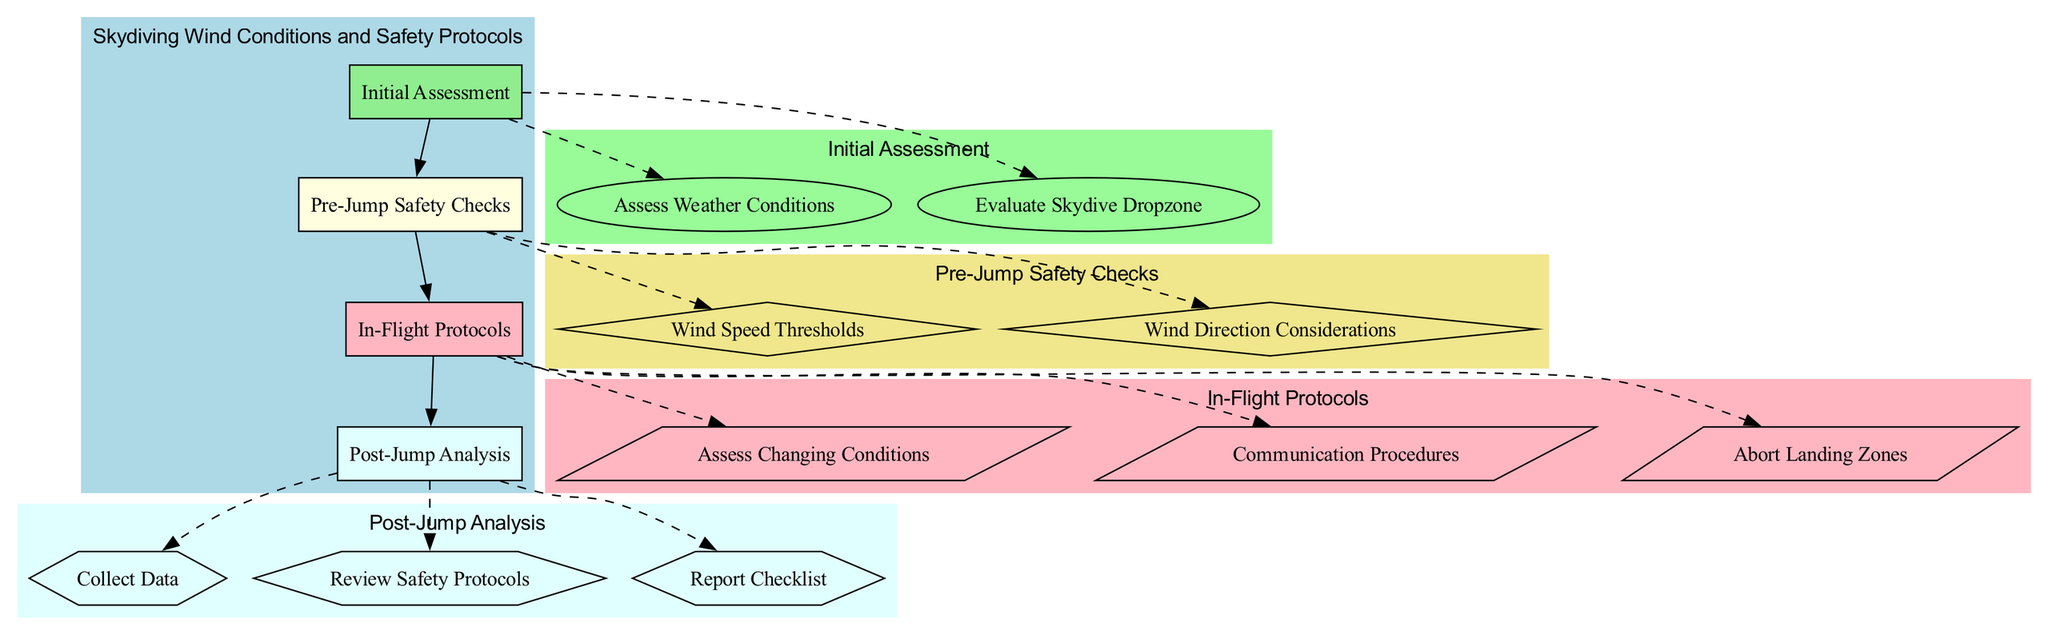What is the maximum wind speed threshold for novice skydivers? The diagram indicates that the maximum wind speed threshold for novice skydivers is specified in the "Wind Speed Thresholds" section under "Pre-Jump Safety Checks."
Answer: Max 15 mph How many main processes are there in the diagram? By examining the nodes in the diagram, there are four main processes: Initial Assessment, Pre-Jump Safety Checks, In-Flight Protocols, and Post-Jump Analysis.
Answer: 4 What communication procedures are used during the in-flight phase? The diagram shows that the communication procedures during the in-flight phase are listed under "In-Flight Protocols," specifically detailing two methods: "Radio Communication" and "Hand Signals."
Answer: Radio Communication, Hand Signals What checks are performed in the initial assessment phase? The diagram reveals that two checks are conducted in the initial assessment phase: "Assess Weather Conditions" and "Evaluate Skydive Dropzone," connected to "Initial Assessment."
Answer: Assess Weather Conditions, Evaluate Skydive Dropzone What is the maximum tailwind limit for skydiving? The "Tailwind Limits" are specified under the "Wind Direction Considerations" in the "Pre-Jump Safety Checks" section of the diagram. The maximum limit is clearly mentioned.
Answer: Max 5 mph Which phase follows "In-Flight Protocols" in the process? The diagram illustrates the flow from "In-Flight Protocols" to "Post-Jump Analysis," indicating which phase comes next in the sequence of processes.
Answer: Post-Jump Analysis What type of data is collected in the post-jump analysis? The "Post-Jump Analysis" section outlines that various types of data are collected, including "GPS Data from Jumpers," "Wind Speed/Direction Logs," and "Weather Anomaly Observations."
Answer: GPS Data from Jumpers, Wind Speed/Direction Logs, Weather Anomaly Observations What is assessed regarding the dropzone? Under the "Evaluate Skydive Dropzone" in the "Initial Assessment," the diagram lists the aspects assessed, which includes "Terrain Type," "Obstacles," and "Landing Zone Size."
Answer: Terrain Type, Obstacles, Landing Zone Size What happens if conditions change during a jump? The diagram states that if conditions change during a jump, the procedures would include "Assess Changing Conditions" and the need for "Real-Time Updates from Ground Crew."
Answer: Assess Changing Conditions, Real-Time Updates from Ground Crew 